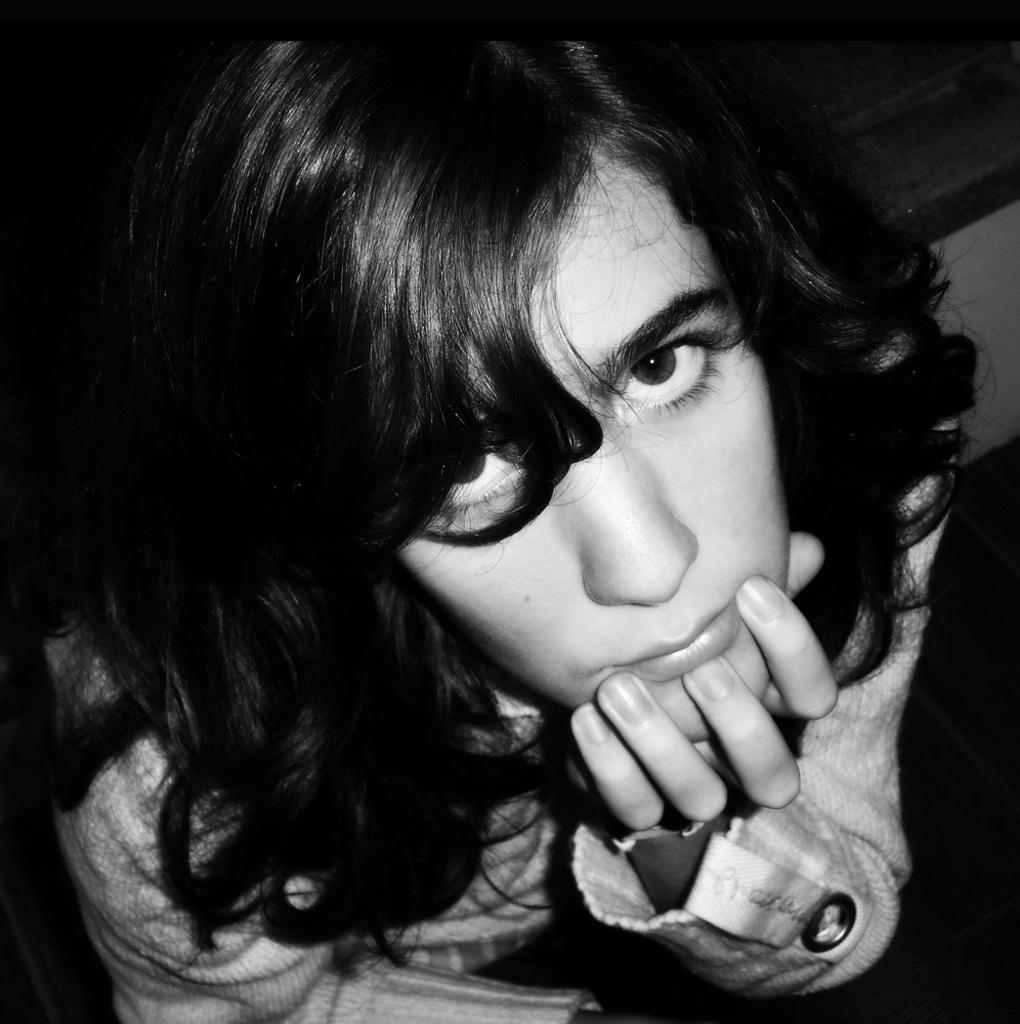Could you give a brief overview of what you see in this image? It is the black and white image of a girls face. 